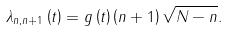Convert formula to latex. <formula><loc_0><loc_0><loc_500><loc_500>\lambda _ { n , n + 1 } \left ( t \right ) = g \left ( t \right ) \left ( n + 1 \right ) \sqrt { N - n } .</formula> 